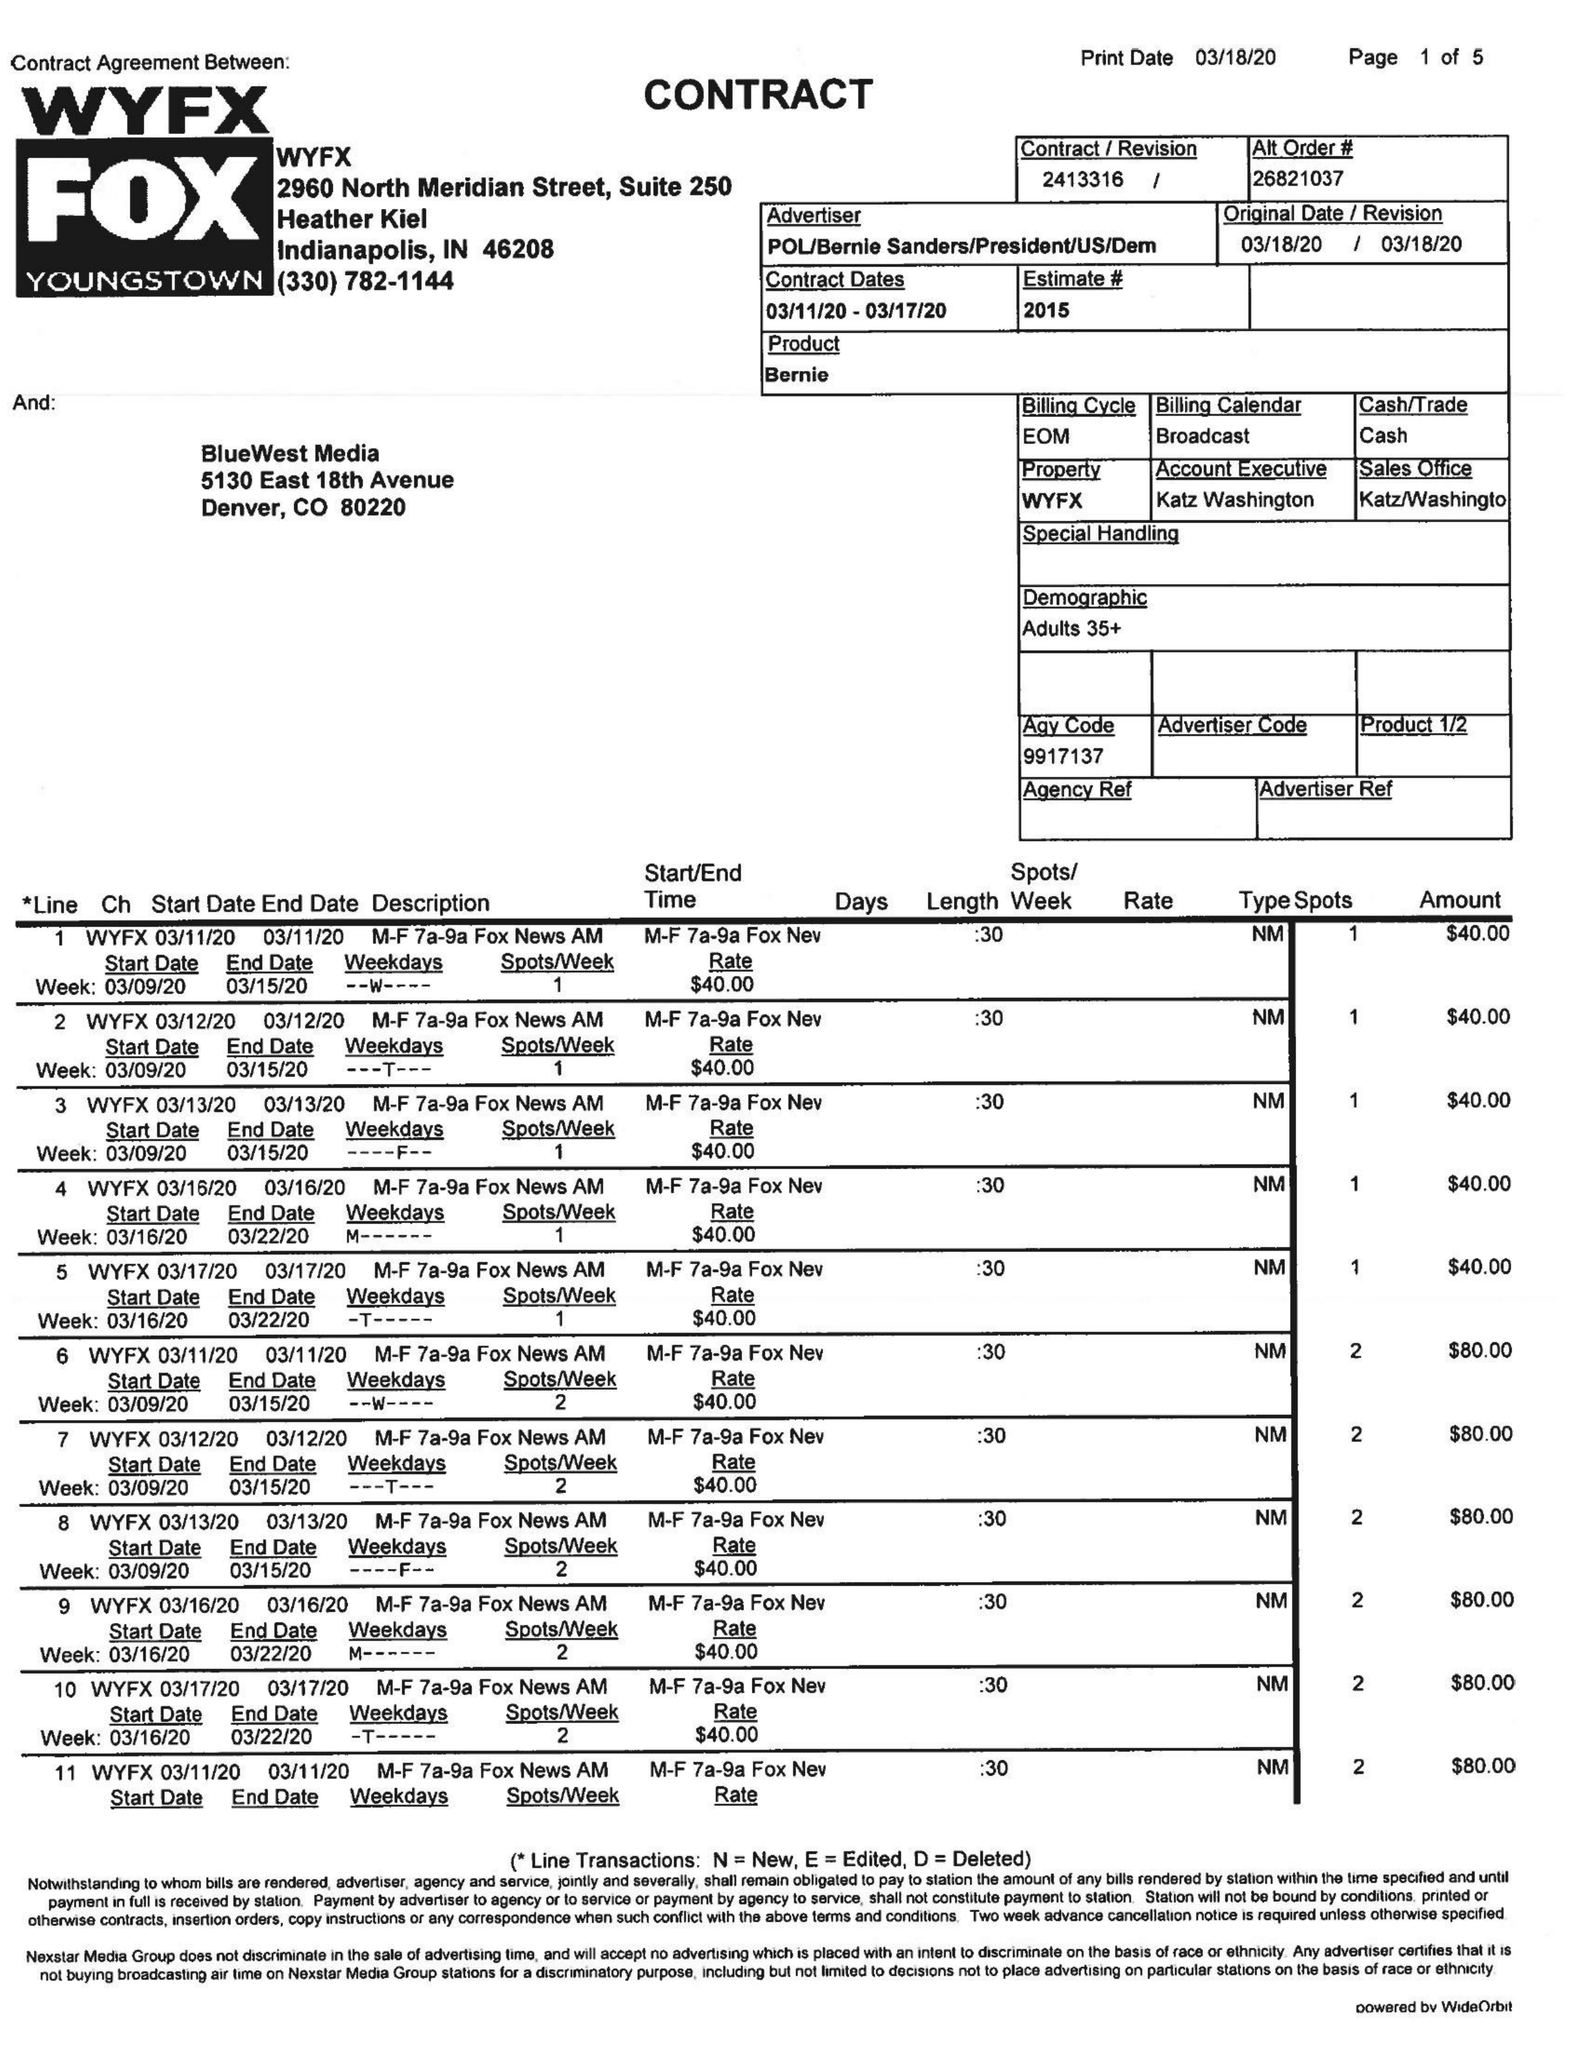What is the value for the advertiser?
Answer the question using a single word or phrase. POL/BERNIESANDERS/PRESIDENT/US/DEM 